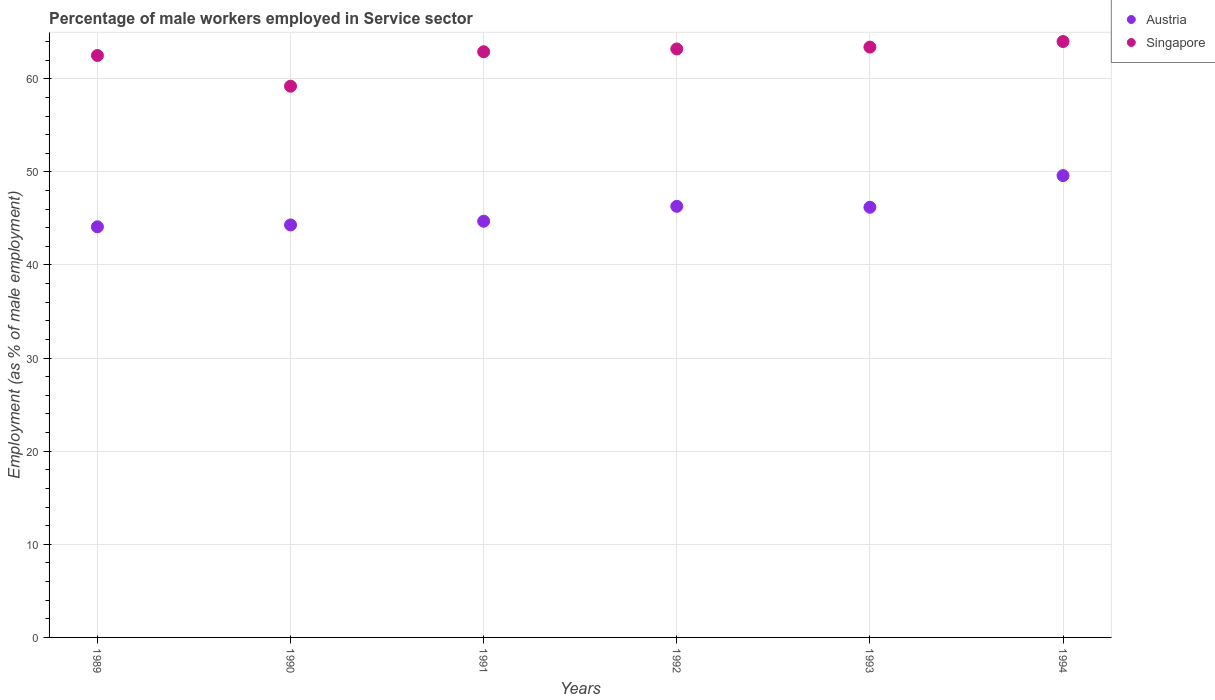How many different coloured dotlines are there?
Ensure brevity in your answer.  2. What is the percentage of male workers employed in Service sector in Singapore in 1990?
Offer a very short reply. 59.2. Across all years, what is the maximum percentage of male workers employed in Service sector in Austria?
Your response must be concise. 49.6. Across all years, what is the minimum percentage of male workers employed in Service sector in Austria?
Give a very brief answer. 44.1. In which year was the percentage of male workers employed in Service sector in Singapore maximum?
Offer a very short reply. 1994. In which year was the percentage of male workers employed in Service sector in Singapore minimum?
Ensure brevity in your answer.  1990. What is the total percentage of male workers employed in Service sector in Austria in the graph?
Keep it short and to the point. 275.2. What is the difference between the percentage of male workers employed in Service sector in Singapore in 1989 and that in 1991?
Provide a short and direct response. -0.4. What is the difference between the percentage of male workers employed in Service sector in Singapore in 1994 and the percentage of male workers employed in Service sector in Austria in 1992?
Ensure brevity in your answer.  17.7. What is the average percentage of male workers employed in Service sector in Singapore per year?
Keep it short and to the point. 62.53. In the year 1994, what is the difference between the percentage of male workers employed in Service sector in Singapore and percentage of male workers employed in Service sector in Austria?
Your response must be concise. 14.4. In how many years, is the percentage of male workers employed in Service sector in Singapore greater than 28 %?
Keep it short and to the point. 6. What is the ratio of the percentage of male workers employed in Service sector in Singapore in 1990 to that in 1992?
Give a very brief answer. 0.94. Is the difference between the percentage of male workers employed in Service sector in Singapore in 1992 and 1993 greater than the difference between the percentage of male workers employed in Service sector in Austria in 1992 and 1993?
Your answer should be compact. No. What is the difference between the highest and the second highest percentage of male workers employed in Service sector in Austria?
Offer a very short reply. 3.3. What is the difference between the highest and the lowest percentage of male workers employed in Service sector in Singapore?
Your response must be concise. 4.8. In how many years, is the percentage of male workers employed in Service sector in Singapore greater than the average percentage of male workers employed in Service sector in Singapore taken over all years?
Your answer should be very brief. 4. Does the percentage of male workers employed in Service sector in Singapore monotonically increase over the years?
Ensure brevity in your answer.  No. Is the percentage of male workers employed in Service sector in Singapore strictly greater than the percentage of male workers employed in Service sector in Austria over the years?
Your answer should be very brief. Yes. Is the percentage of male workers employed in Service sector in Singapore strictly less than the percentage of male workers employed in Service sector in Austria over the years?
Make the answer very short. No. How many dotlines are there?
Keep it short and to the point. 2. How many years are there in the graph?
Your answer should be very brief. 6. What is the difference between two consecutive major ticks on the Y-axis?
Your response must be concise. 10. Are the values on the major ticks of Y-axis written in scientific E-notation?
Provide a short and direct response. No. Does the graph contain any zero values?
Give a very brief answer. No. Does the graph contain grids?
Provide a short and direct response. Yes. Where does the legend appear in the graph?
Offer a terse response. Top right. What is the title of the graph?
Provide a short and direct response. Percentage of male workers employed in Service sector. Does "Malta" appear as one of the legend labels in the graph?
Offer a terse response. No. What is the label or title of the X-axis?
Offer a terse response. Years. What is the label or title of the Y-axis?
Offer a terse response. Employment (as % of male employment). What is the Employment (as % of male employment) in Austria in 1989?
Your answer should be compact. 44.1. What is the Employment (as % of male employment) in Singapore in 1989?
Ensure brevity in your answer.  62.5. What is the Employment (as % of male employment) of Austria in 1990?
Provide a succinct answer. 44.3. What is the Employment (as % of male employment) in Singapore in 1990?
Your answer should be very brief. 59.2. What is the Employment (as % of male employment) of Austria in 1991?
Keep it short and to the point. 44.7. What is the Employment (as % of male employment) in Singapore in 1991?
Provide a succinct answer. 62.9. What is the Employment (as % of male employment) of Austria in 1992?
Ensure brevity in your answer.  46.3. What is the Employment (as % of male employment) of Singapore in 1992?
Provide a short and direct response. 63.2. What is the Employment (as % of male employment) of Austria in 1993?
Give a very brief answer. 46.2. What is the Employment (as % of male employment) of Singapore in 1993?
Keep it short and to the point. 63.4. What is the Employment (as % of male employment) of Austria in 1994?
Make the answer very short. 49.6. What is the Employment (as % of male employment) of Singapore in 1994?
Provide a short and direct response. 64. Across all years, what is the maximum Employment (as % of male employment) of Austria?
Ensure brevity in your answer.  49.6. Across all years, what is the maximum Employment (as % of male employment) in Singapore?
Your response must be concise. 64. Across all years, what is the minimum Employment (as % of male employment) of Austria?
Offer a terse response. 44.1. Across all years, what is the minimum Employment (as % of male employment) of Singapore?
Provide a succinct answer. 59.2. What is the total Employment (as % of male employment) in Austria in the graph?
Your answer should be very brief. 275.2. What is the total Employment (as % of male employment) of Singapore in the graph?
Your response must be concise. 375.2. What is the difference between the Employment (as % of male employment) of Singapore in 1989 and that in 1990?
Make the answer very short. 3.3. What is the difference between the Employment (as % of male employment) of Austria in 1989 and that in 1992?
Your answer should be very brief. -2.2. What is the difference between the Employment (as % of male employment) in Singapore in 1989 and that in 1992?
Offer a very short reply. -0.7. What is the difference between the Employment (as % of male employment) of Austria in 1989 and that in 1994?
Provide a succinct answer. -5.5. What is the difference between the Employment (as % of male employment) of Austria in 1990 and that in 1991?
Provide a succinct answer. -0.4. What is the difference between the Employment (as % of male employment) of Austria in 1990 and that in 1992?
Give a very brief answer. -2. What is the difference between the Employment (as % of male employment) in Austria in 1990 and that in 1993?
Your response must be concise. -1.9. What is the difference between the Employment (as % of male employment) in Austria in 1990 and that in 1994?
Your response must be concise. -5.3. What is the difference between the Employment (as % of male employment) in Singapore in 1991 and that in 1993?
Give a very brief answer. -0.5. What is the difference between the Employment (as % of male employment) in Singapore in 1991 and that in 1994?
Your response must be concise. -1.1. What is the difference between the Employment (as % of male employment) in Singapore in 1992 and that in 1993?
Your answer should be very brief. -0.2. What is the difference between the Employment (as % of male employment) in Austria in 1992 and that in 1994?
Provide a succinct answer. -3.3. What is the difference between the Employment (as % of male employment) in Singapore in 1993 and that in 1994?
Give a very brief answer. -0.6. What is the difference between the Employment (as % of male employment) of Austria in 1989 and the Employment (as % of male employment) of Singapore in 1990?
Your answer should be compact. -15.1. What is the difference between the Employment (as % of male employment) of Austria in 1989 and the Employment (as % of male employment) of Singapore in 1991?
Keep it short and to the point. -18.8. What is the difference between the Employment (as % of male employment) in Austria in 1989 and the Employment (as % of male employment) in Singapore in 1992?
Your response must be concise. -19.1. What is the difference between the Employment (as % of male employment) of Austria in 1989 and the Employment (as % of male employment) of Singapore in 1993?
Provide a succinct answer. -19.3. What is the difference between the Employment (as % of male employment) in Austria in 1989 and the Employment (as % of male employment) in Singapore in 1994?
Make the answer very short. -19.9. What is the difference between the Employment (as % of male employment) in Austria in 1990 and the Employment (as % of male employment) in Singapore in 1991?
Your response must be concise. -18.6. What is the difference between the Employment (as % of male employment) of Austria in 1990 and the Employment (as % of male employment) of Singapore in 1992?
Offer a very short reply. -18.9. What is the difference between the Employment (as % of male employment) of Austria in 1990 and the Employment (as % of male employment) of Singapore in 1993?
Provide a succinct answer. -19.1. What is the difference between the Employment (as % of male employment) of Austria in 1990 and the Employment (as % of male employment) of Singapore in 1994?
Your answer should be compact. -19.7. What is the difference between the Employment (as % of male employment) of Austria in 1991 and the Employment (as % of male employment) of Singapore in 1992?
Keep it short and to the point. -18.5. What is the difference between the Employment (as % of male employment) in Austria in 1991 and the Employment (as % of male employment) in Singapore in 1993?
Your response must be concise. -18.7. What is the difference between the Employment (as % of male employment) in Austria in 1991 and the Employment (as % of male employment) in Singapore in 1994?
Keep it short and to the point. -19.3. What is the difference between the Employment (as % of male employment) in Austria in 1992 and the Employment (as % of male employment) in Singapore in 1993?
Provide a short and direct response. -17.1. What is the difference between the Employment (as % of male employment) of Austria in 1992 and the Employment (as % of male employment) of Singapore in 1994?
Offer a terse response. -17.7. What is the difference between the Employment (as % of male employment) of Austria in 1993 and the Employment (as % of male employment) of Singapore in 1994?
Make the answer very short. -17.8. What is the average Employment (as % of male employment) in Austria per year?
Keep it short and to the point. 45.87. What is the average Employment (as % of male employment) in Singapore per year?
Offer a terse response. 62.53. In the year 1989, what is the difference between the Employment (as % of male employment) in Austria and Employment (as % of male employment) in Singapore?
Provide a succinct answer. -18.4. In the year 1990, what is the difference between the Employment (as % of male employment) of Austria and Employment (as % of male employment) of Singapore?
Ensure brevity in your answer.  -14.9. In the year 1991, what is the difference between the Employment (as % of male employment) in Austria and Employment (as % of male employment) in Singapore?
Give a very brief answer. -18.2. In the year 1992, what is the difference between the Employment (as % of male employment) in Austria and Employment (as % of male employment) in Singapore?
Offer a very short reply. -16.9. In the year 1993, what is the difference between the Employment (as % of male employment) of Austria and Employment (as % of male employment) of Singapore?
Your answer should be compact. -17.2. In the year 1994, what is the difference between the Employment (as % of male employment) in Austria and Employment (as % of male employment) in Singapore?
Your response must be concise. -14.4. What is the ratio of the Employment (as % of male employment) in Austria in 1989 to that in 1990?
Provide a short and direct response. 1. What is the ratio of the Employment (as % of male employment) in Singapore in 1989 to that in 1990?
Your response must be concise. 1.06. What is the ratio of the Employment (as % of male employment) in Austria in 1989 to that in 1991?
Ensure brevity in your answer.  0.99. What is the ratio of the Employment (as % of male employment) of Singapore in 1989 to that in 1991?
Your response must be concise. 0.99. What is the ratio of the Employment (as % of male employment) of Austria in 1989 to that in 1992?
Your response must be concise. 0.95. What is the ratio of the Employment (as % of male employment) in Singapore in 1989 to that in 1992?
Offer a terse response. 0.99. What is the ratio of the Employment (as % of male employment) in Austria in 1989 to that in 1993?
Give a very brief answer. 0.95. What is the ratio of the Employment (as % of male employment) in Singapore in 1989 to that in 1993?
Keep it short and to the point. 0.99. What is the ratio of the Employment (as % of male employment) of Austria in 1989 to that in 1994?
Your answer should be compact. 0.89. What is the ratio of the Employment (as % of male employment) in Singapore in 1989 to that in 1994?
Offer a very short reply. 0.98. What is the ratio of the Employment (as % of male employment) of Austria in 1990 to that in 1991?
Offer a very short reply. 0.99. What is the ratio of the Employment (as % of male employment) of Austria in 1990 to that in 1992?
Provide a succinct answer. 0.96. What is the ratio of the Employment (as % of male employment) of Singapore in 1990 to that in 1992?
Provide a short and direct response. 0.94. What is the ratio of the Employment (as % of male employment) of Austria in 1990 to that in 1993?
Your answer should be very brief. 0.96. What is the ratio of the Employment (as % of male employment) of Singapore in 1990 to that in 1993?
Offer a very short reply. 0.93. What is the ratio of the Employment (as % of male employment) in Austria in 1990 to that in 1994?
Your answer should be very brief. 0.89. What is the ratio of the Employment (as % of male employment) of Singapore in 1990 to that in 1994?
Your response must be concise. 0.93. What is the ratio of the Employment (as % of male employment) of Austria in 1991 to that in 1992?
Ensure brevity in your answer.  0.97. What is the ratio of the Employment (as % of male employment) of Austria in 1991 to that in 1993?
Ensure brevity in your answer.  0.97. What is the ratio of the Employment (as % of male employment) in Singapore in 1991 to that in 1993?
Offer a terse response. 0.99. What is the ratio of the Employment (as % of male employment) in Austria in 1991 to that in 1994?
Your answer should be very brief. 0.9. What is the ratio of the Employment (as % of male employment) in Singapore in 1991 to that in 1994?
Make the answer very short. 0.98. What is the ratio of the Employment (as % of male employment) in Austria in 1992 to that in 1993?
Keep it short and to the point. 1. What is the ratio of the Employment (as % of male employment) in Singapore in 1992 to that in 1993?
Your response must be concise. 1. What is the ratio of the Employment (as % of male employment) of Austria in 1992 to that in 1994?
Offer a terse response. 0.93. What is the ratio of the Employment (as % of male employment) in Singapore in 1992 to that in 1994?
Keep it short and to the point. 0.99. What is the ratio of the Employment (as % of male employment) in Austria in 1993 to that in 1994?
Ensure brevity in your answer.  0.93. What is the ratio of the Employment (as % of male employment) in Singapore in 1993 to that in 1994?
Ensure brevity in your answer.  0.99. What is the difference between the highest and the second highest Employment (as % of male employment) in Singapore?
Offer a very short reply. 0.6. 